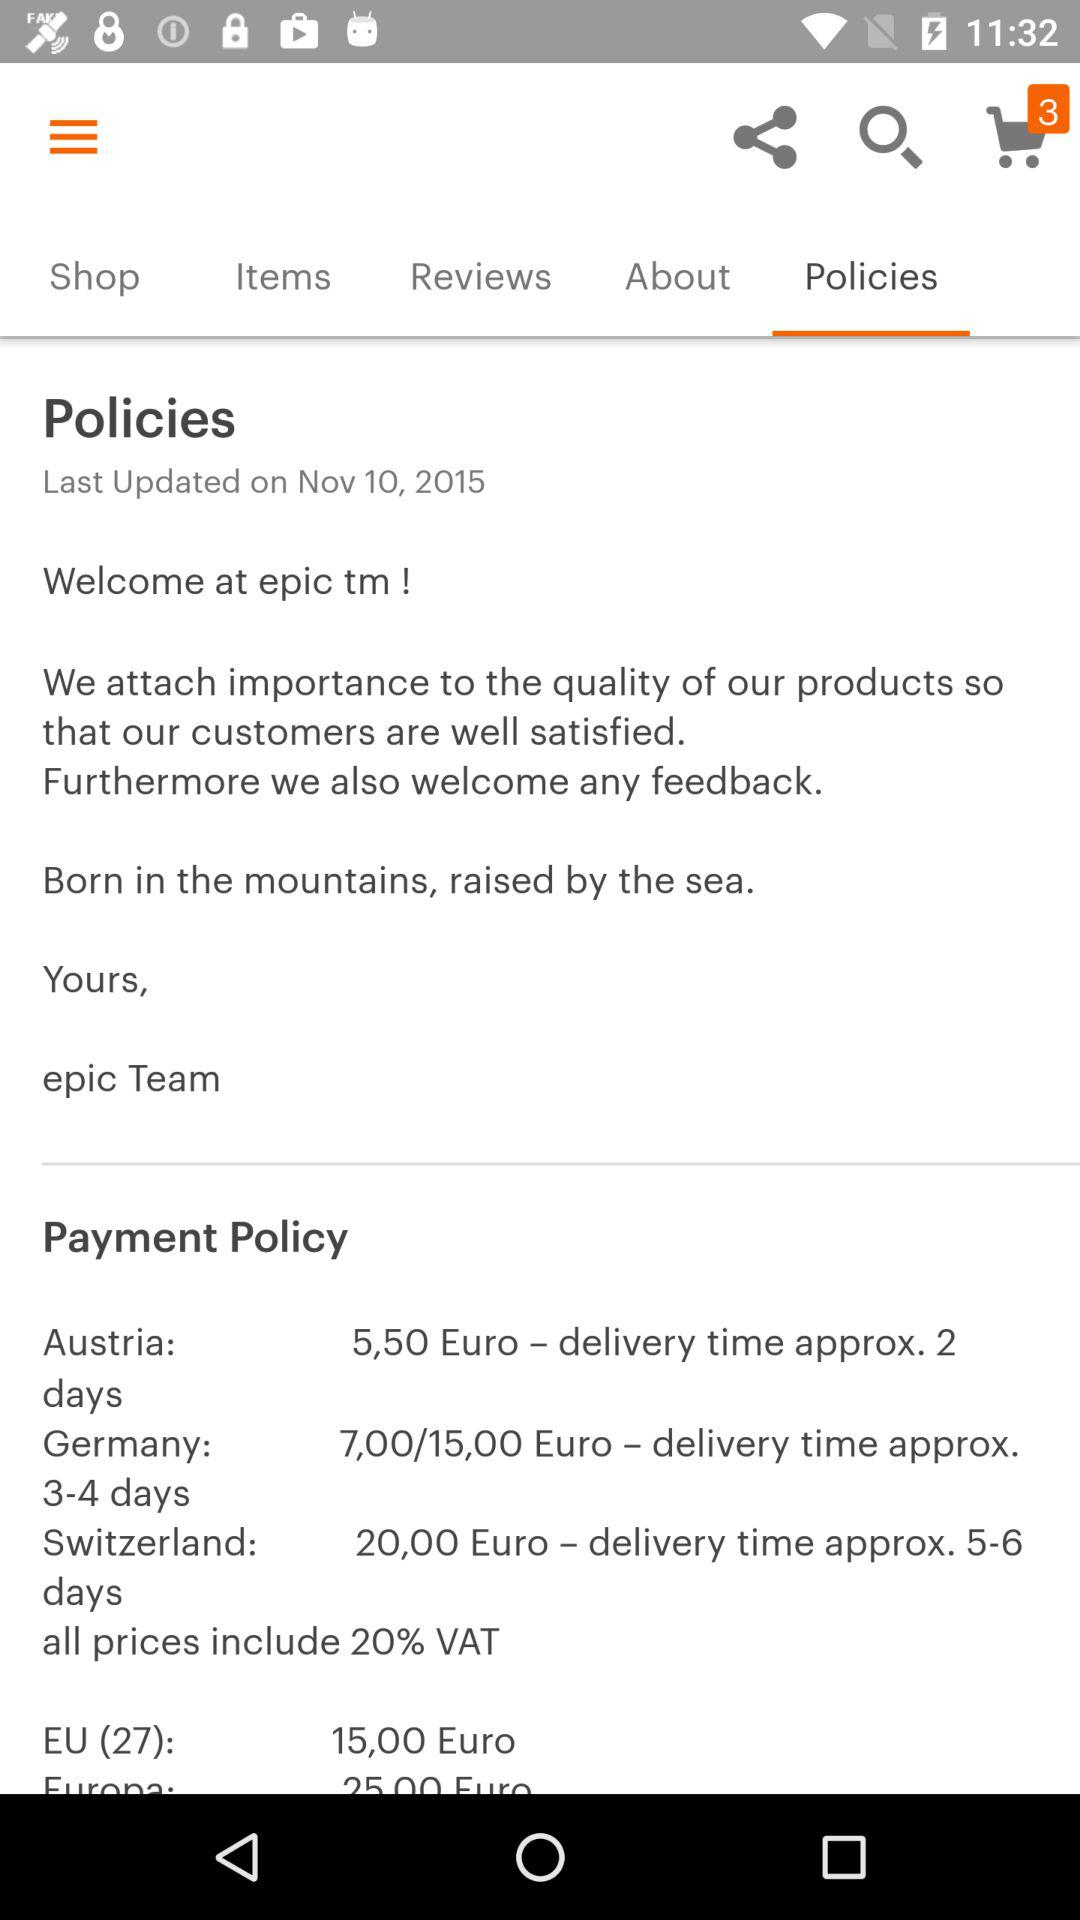How much VAT is included in all prices? All prices include 20% VAT. 